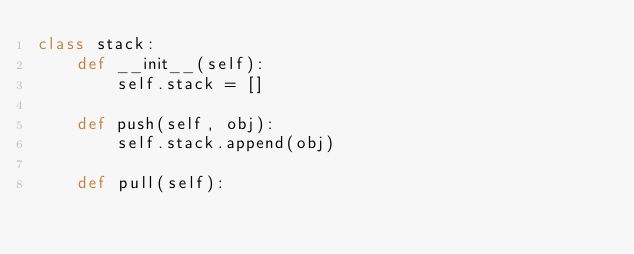Convert code to text. <code><loc_0><loc_0><loc_500><loc_500><_Python_>class stack:
    def __init__(self):
        self.stack = []

    def push(self, obj):
        self.stack.append(obj)

    def pull(self):</code> 